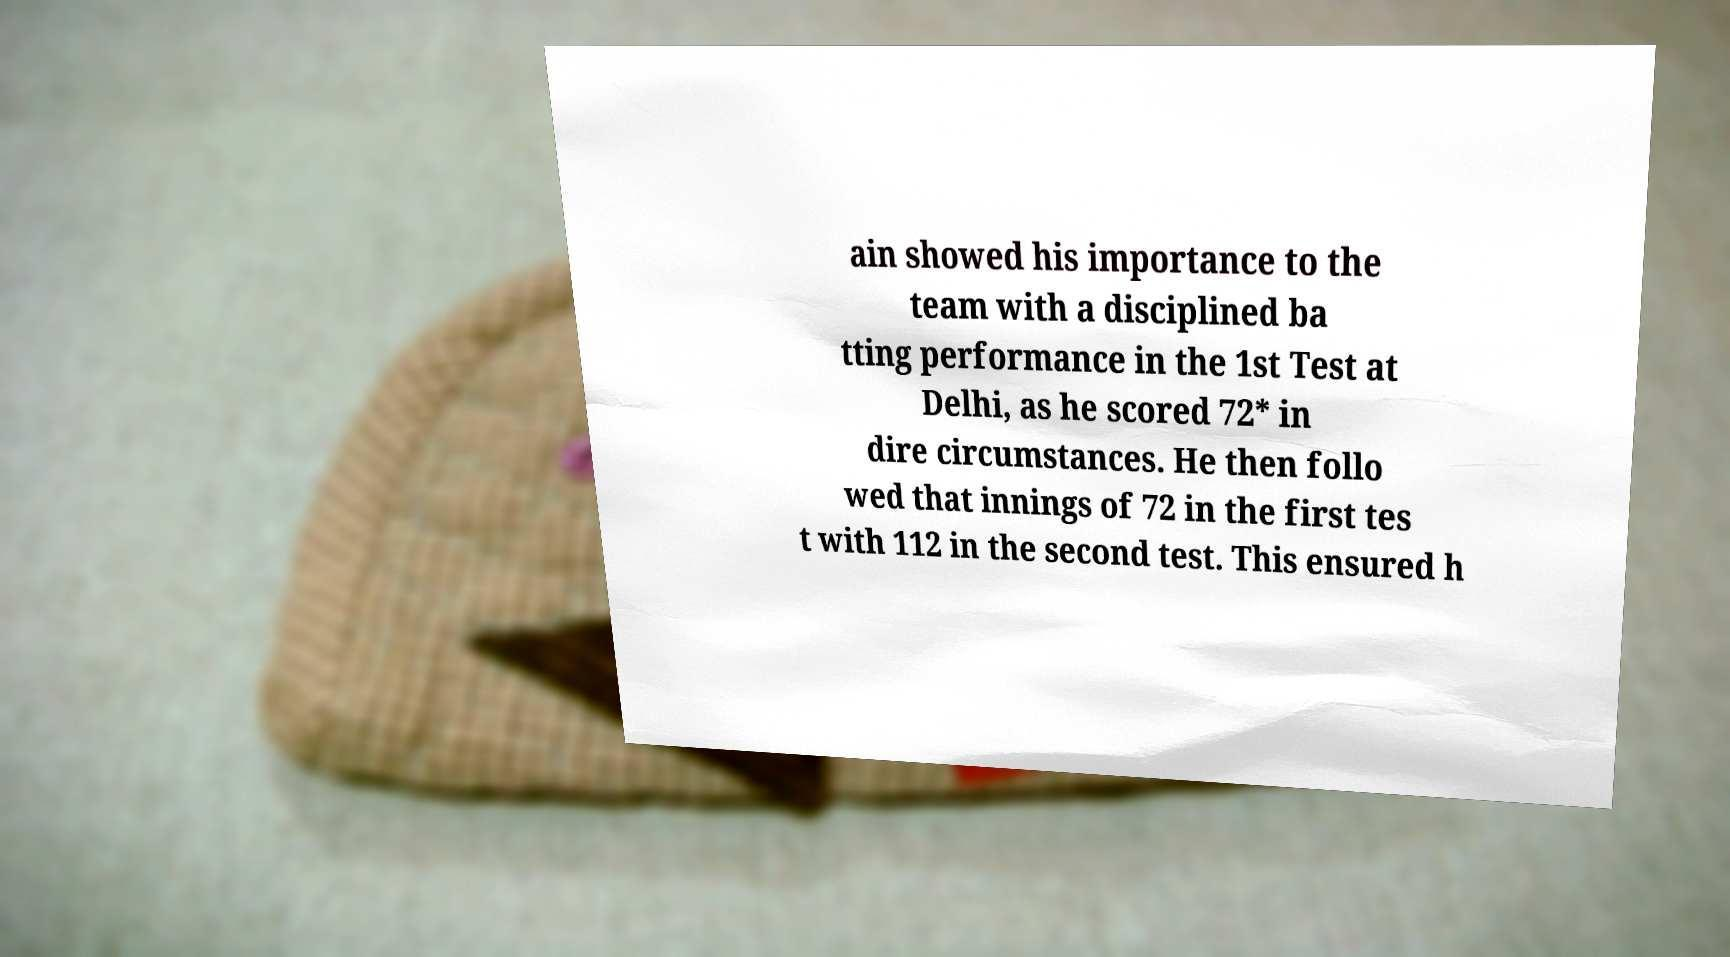Can you read and provide the text displayed in the image?This photo seems to have some interesting text. Can you extract and type it out for me? ain showed his importance to the team with a disciplined ba tting performance in the 1st Test at Delhi, as he scored 72* in dire circumstances. He then follo wed that innings of 72 in the first tes t with 112 in the second test. This ensured h 